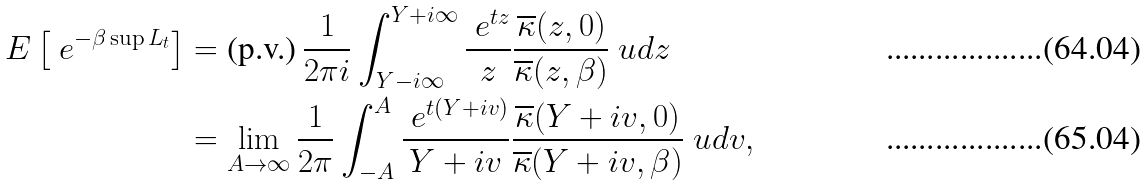<formula> <loc_0><loc_0><loc_500><loc_500>E \left [ \ e ^ { - \beta \sup L _ { t } } \right ] & = \text {(p.v.)} \, \frac { 1 } { 2 \pi i } \int _ { Y - i \infty } ^ { Y + i \infty } \frac { \ e ^ { t z } } { z } \frac { \overline { \kappa } ( z , 0 ) } { \overline { \kappa } ( z , \beta ) } \ u d z \\ & = \lim _ { A \to \infty } \frac { 1 } { 2 \pi } \int _ { - A } ^ { A } \frac { \ e ^ { t ( Y + i v ) } } { Y + i v } \frac { \overline { \kappa } ( Y + i v , 0 ) } { \overline { \kappa } ( Y + i v , \beta ) } \ u d v ,</formula> 